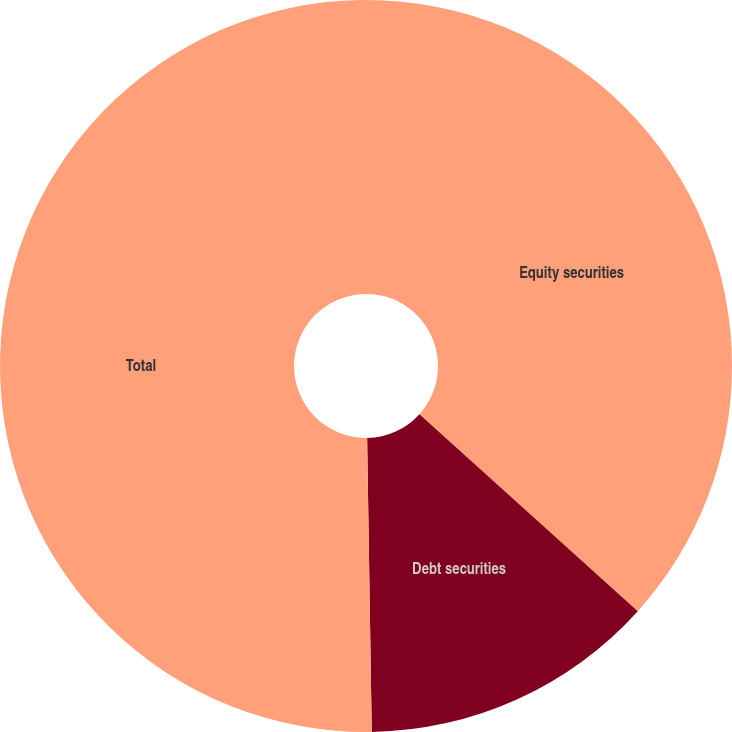Convert chart to OTSL. <chart><loc_0><loc_0><loc_500><loc_500><pie_chart><fcel>Equity securities<fcel>Debt securities<fcel>Total<nl><fcel>36.68%<fcel>13.07%<fcel>50.25%<nl></chart> 